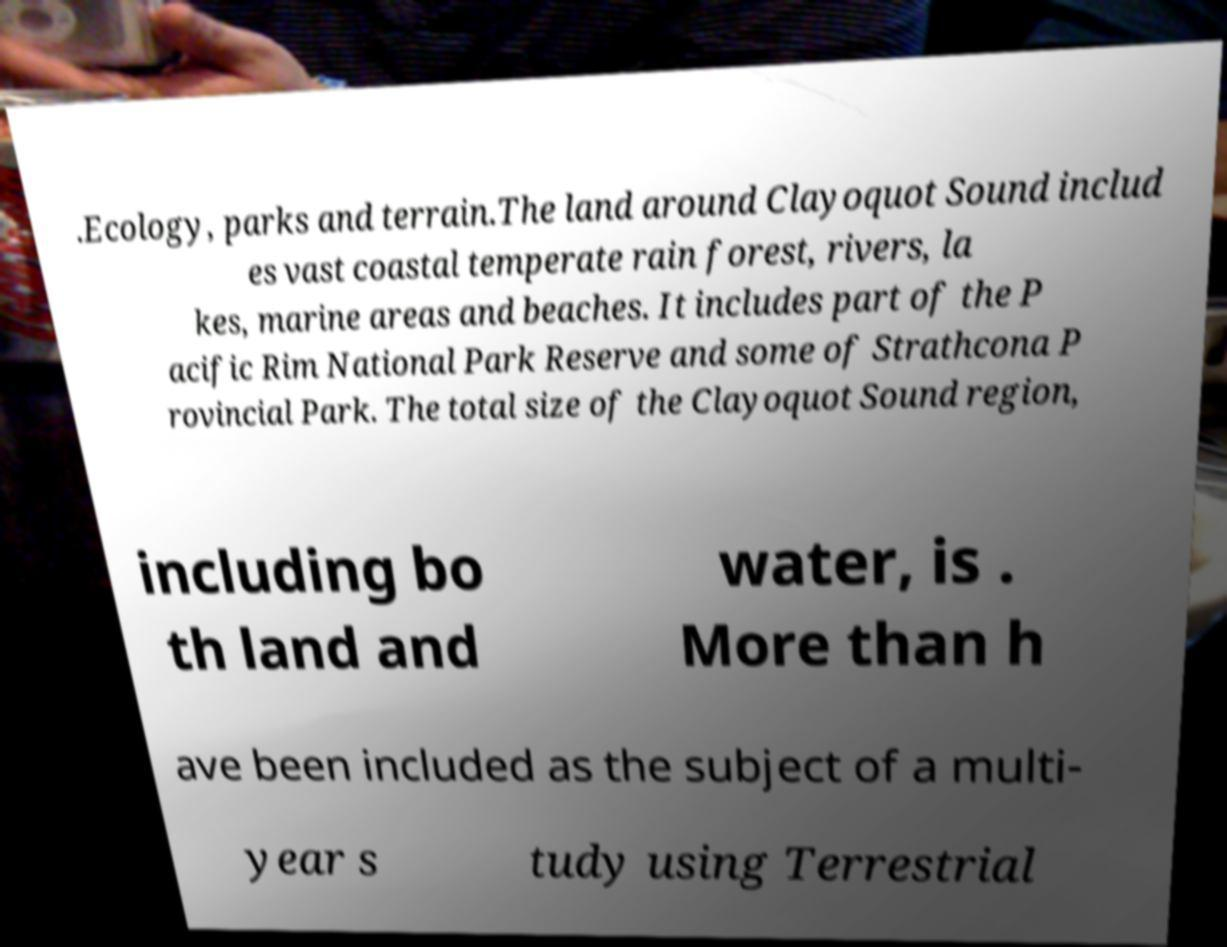Can you read and provide the text displayed in the image?This photo seems to have some interesting text. Can you extract and type it out for me? .Ecology, parks and terrain.The land around Clayoquot Sound includ es vast coastal temperate rain forest, rivers, la kes, marine areas and beaches. It includes part of the P acific Rim National Park Reserve and some of Strathcona P rovincial Park. The total size of the Clayoquot Sound region, including bo th land and water, is . More than h ave been included as the subject of a multi- year s tudy using Terrestrial 